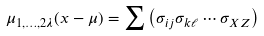Convert formula to latex. <formula><loc_0><loc_0><loc_500><loc_500>\mu _ { 1 , \dots , 2 \lambda } ( x - { \mu } ) = \sum \left ( \sigma _ { i j } \sigma _ { k \ell } \cdots \sigma _ { X Z } \right )</formula> 